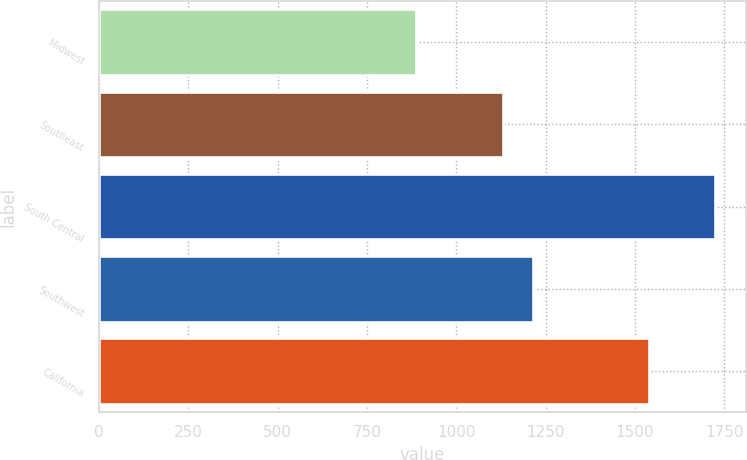<chart> <loc_0><loc_0><loc_500><loc_500><bar_chart><fcel>Midwest<fcel>Southeast<fcel>South Central<fcel>Southwest<fcel>California<nl><fcel>887<fcel>1130.4<fcel>1723.5<fcel>1214.05<fcel>1539.6<nl></chart> 